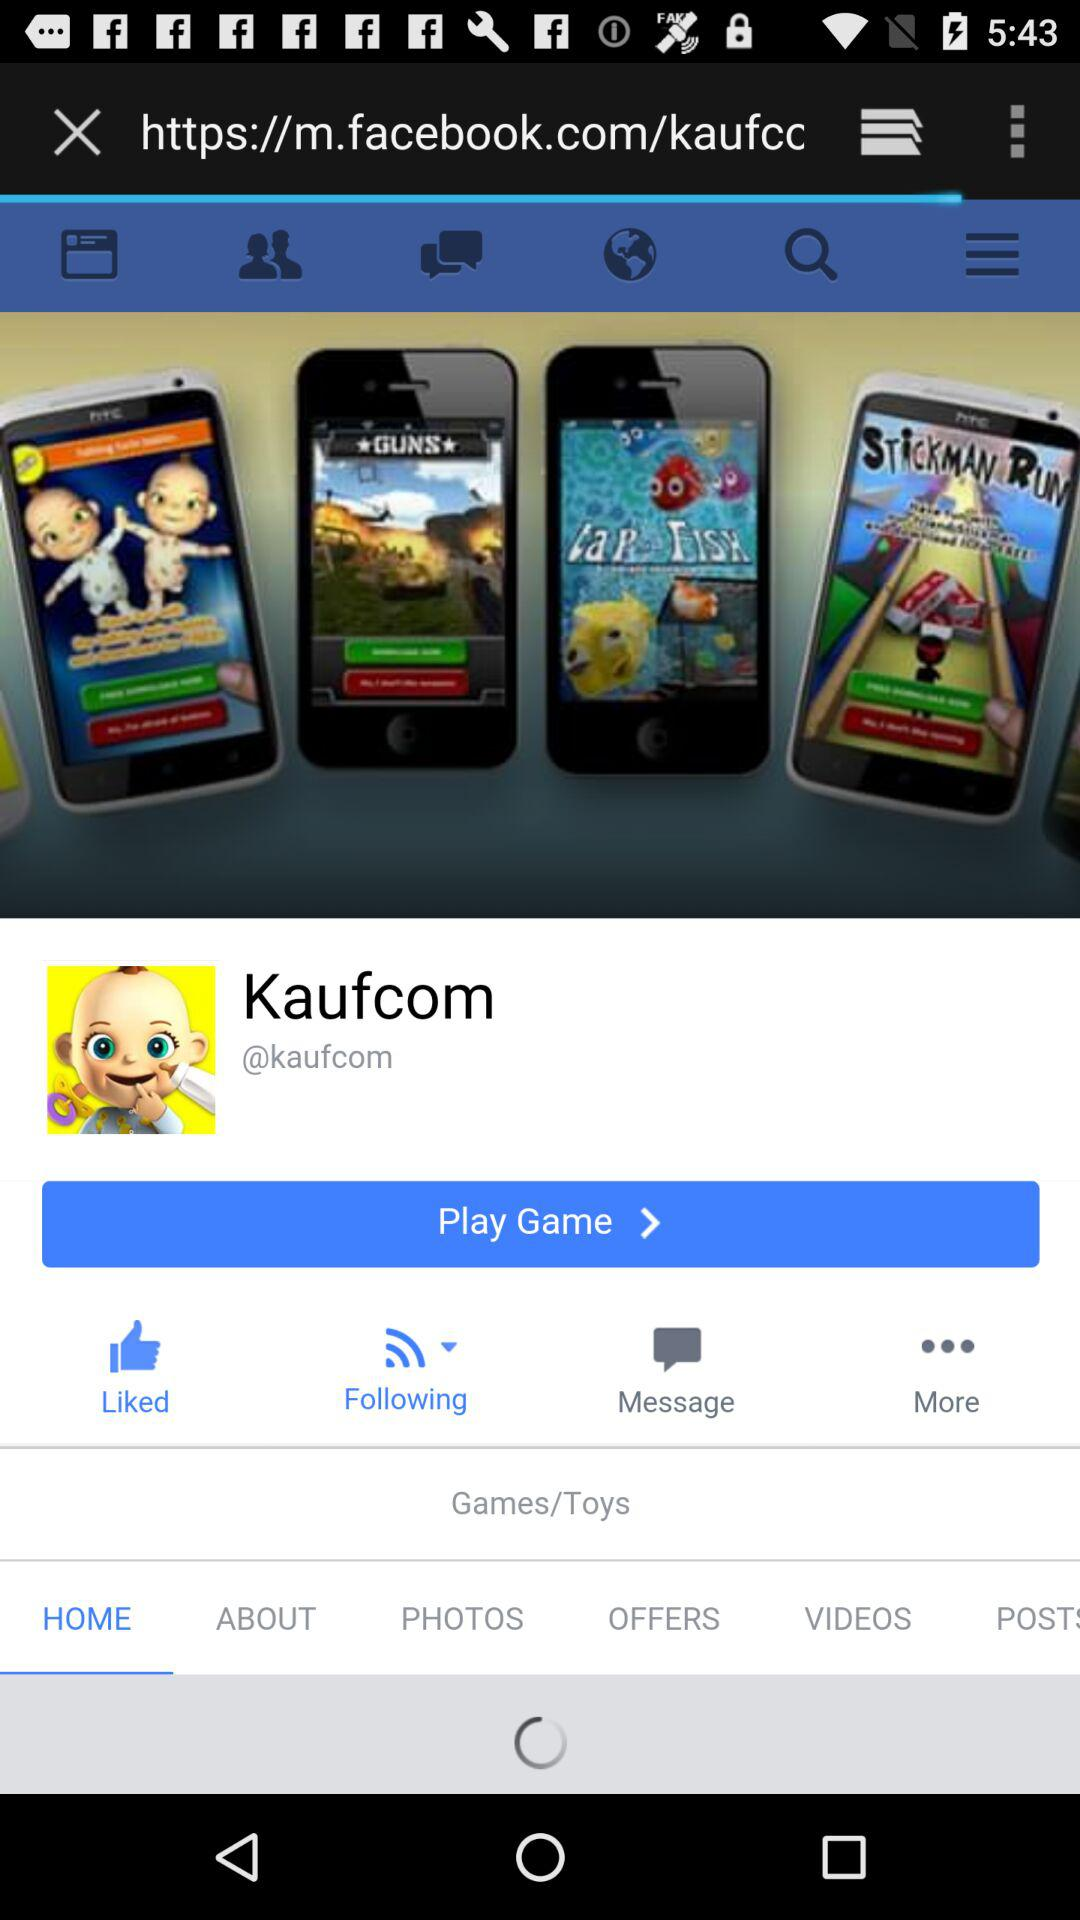Which tab is selected? The selected tab is "HOME". 